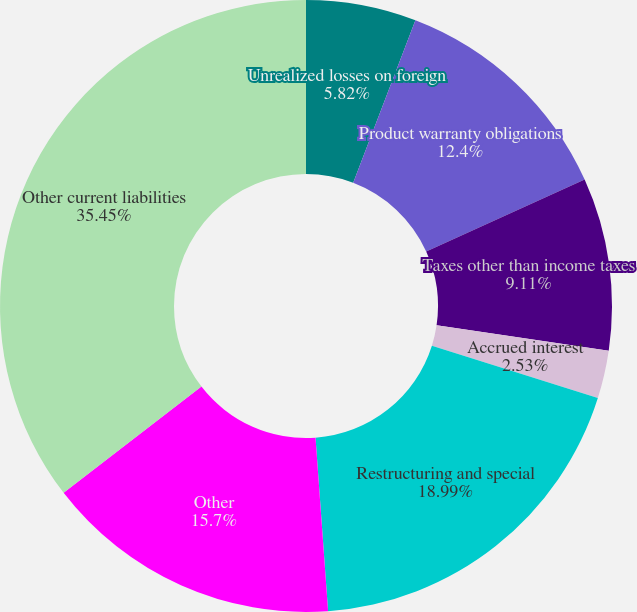<chart> <loc_0><loc_0><loc_500><loc_500><pie_chart><fcel>Unrealized losses on foreign<fcel>Product warranty obligations<fcel>Taxes other than income taxes<fcel>Accrued interest<fcel>Restructuring and special<fcel>Other<fcel>Other current liabilities<nl><fcel>5.82%<fcel>12.4%<fcel>9.11%<fcel>2.53%<fcel>18.99%<fcel>15.7%<fcel>35.45%<nl></chart> 